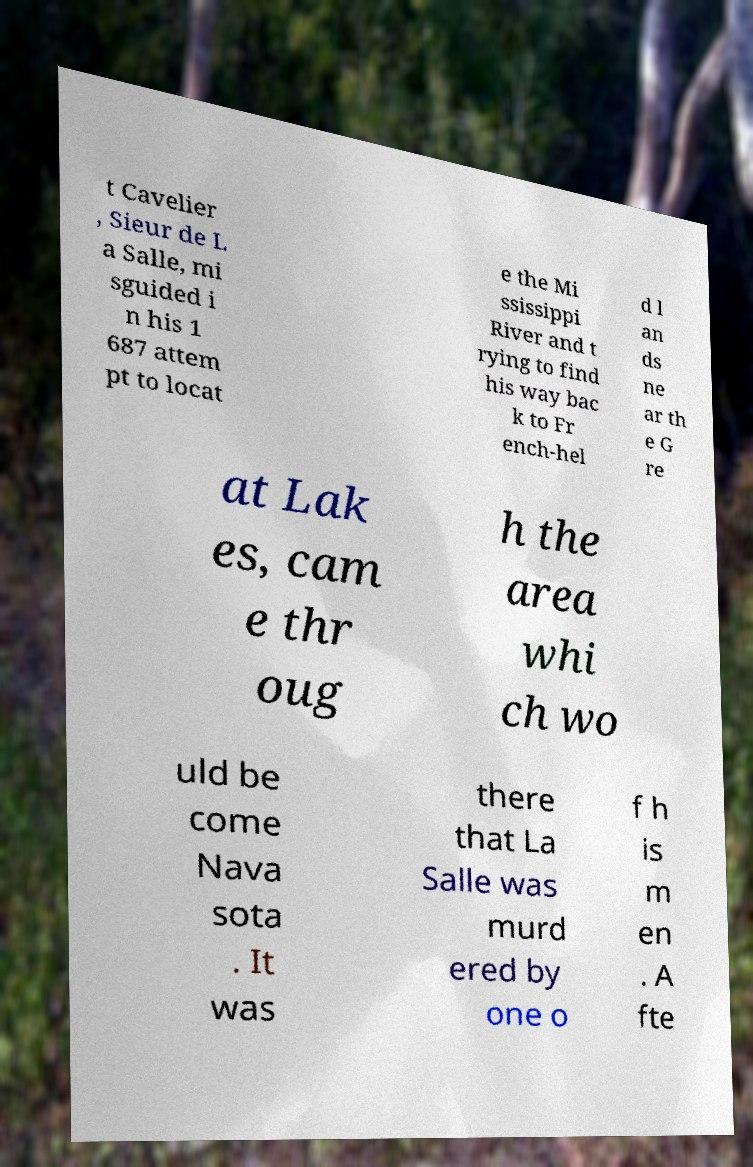Please read and relay the text visible in this image. What does it say? t Cavelier , Sieur de L a Salle, mi sguided i n his 1 687 attem pt to locat e the Mi ssissippi River and t rying to find his way bac k to Fr ench-hel d l an ds ne ar th e G re at Lak es, cam e thr oug h the area whi ch wo uld be come Nava sota . It was there that La Salle was murd ered by one o f h is m en . A fte 